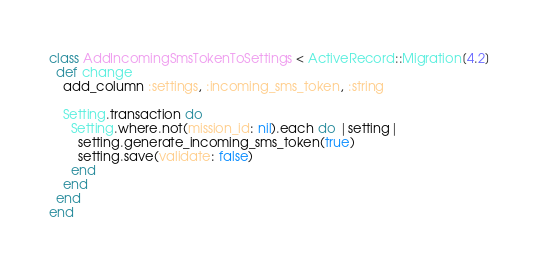Convert code to text. <code><loc_0><loc_0><loc_500><loc_500><_Ruby_>class AddIncomingSmsTokenToSettings < ActiveRecord::Migration[4.2]
  def change
    add_column :settings, :incoming_sms_token, :string

    Setting.transaction do
      Setting.where.not(mission_id: nil).each do |setting|
        setting.generate_incoming_sms_token(true)
        setting.save(validate: false)
      end
    end
  end
end
</code> 